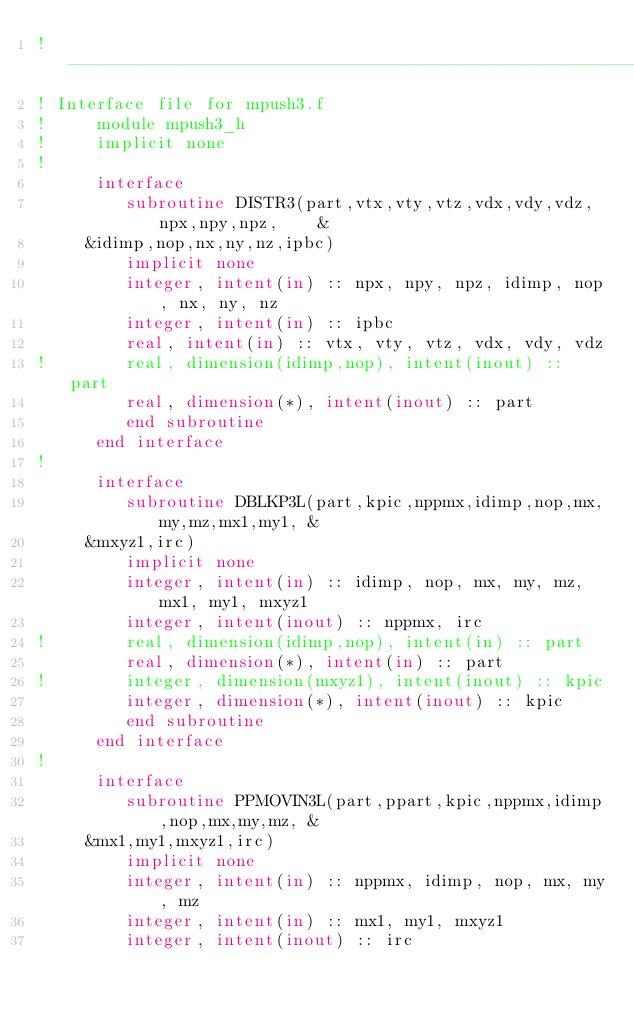<code> <loc_0><loc_0><loc_500><loc_500><_FORTRAN_>!-----------------------------------------------------------------------
! Interface file for mpush3.f
!     module mpush3_h
!     implicit none
!
      interface
         subroutine DISTR3(part,vtx,vty,vtz,vdx,vdy,vdz,npx,npy,npz,    &
     &idimp,nop,nx,ny,nz,ipbc)
         implicit none
         integer, intent(in) :: npx, npy, npz, idimp, nop, nx, ny, nz
         integer, intent(in) :: ipbc
         real, intent(in) :: vtx, vty, vtz, vdx, vdy, vdz
!        real, dimension(idimp,nop), intent(inout) :: part
         real, dimension(*), intent(inout) :: part
         end subroutine
      end interface
!
      interface
         subroutine DBLKP3L(part,kpic,nppmx,idimp,nop,mx,my,mz,mx1,my1, &
     &mxyz1,irc)
         implicit none
         integer, intent(in) :: idimp, nop, mx, my, mz, mx1, my1, mxyz1
         integer, intent(inout) :: nppmx, irc
!        real, dimension(idimp,nop), intent(in) :: part
         real, dimension(*), intent(in) :: part
!        integer, dimension(mxyz1), intent(inout) :: kpic
         integer, dimension(*), intent(inout) :: kpic
         end subroutine
      end interface
!
      interface
         subroutine PPMOVIN3L(part,ppart,kpic,nppmx,idimp,nop,mx,my,mz, &
     &mx1,my1,mxyz1,irc)
         implicit none
         integer, intent(in) :: nppmx, idimp, nop, mx, my, mz
         integer, intent(in) :: mx1, my1, mxyz1
         integer, intent(inout) :: irc</code> 